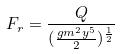Convert formula to latex. <formula><loc_0><loc_0><loc_500><loc_500>F _ { r } = \frac { Q } { ( \frac { g m ^ { 2 } y ^ { 5 } } { 2 } ) ^ { \frac { 1 } { 2 } } }</formula> 